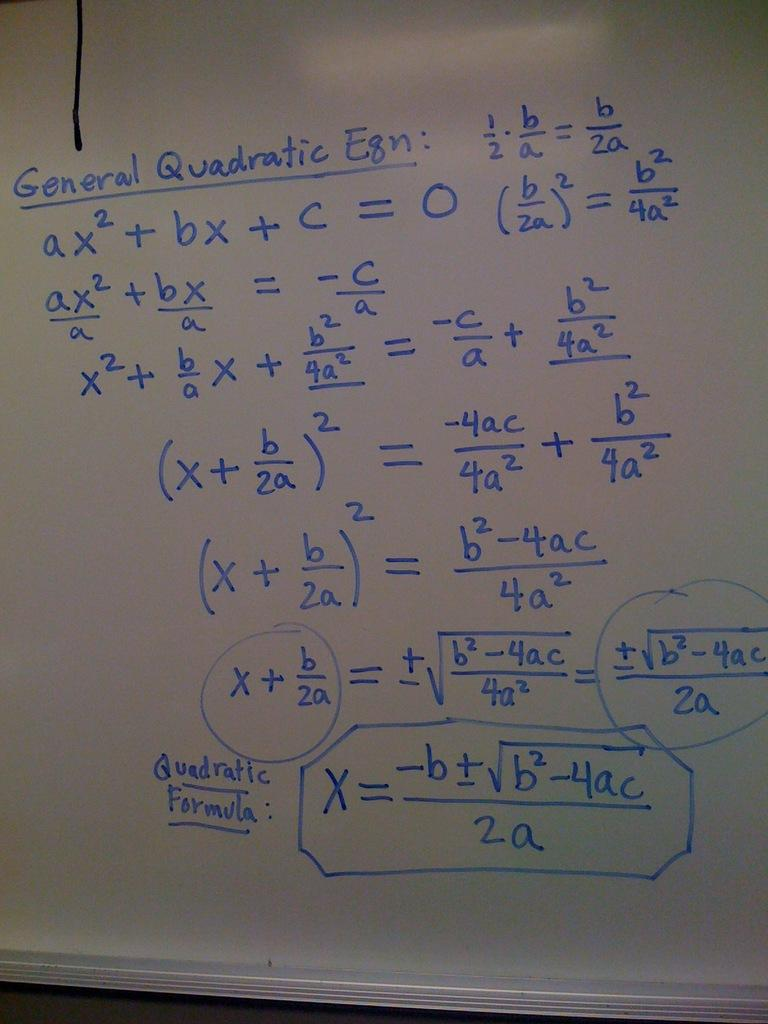<image>
Describe the image concisely. A whiteboard has General Quadratic written on it 